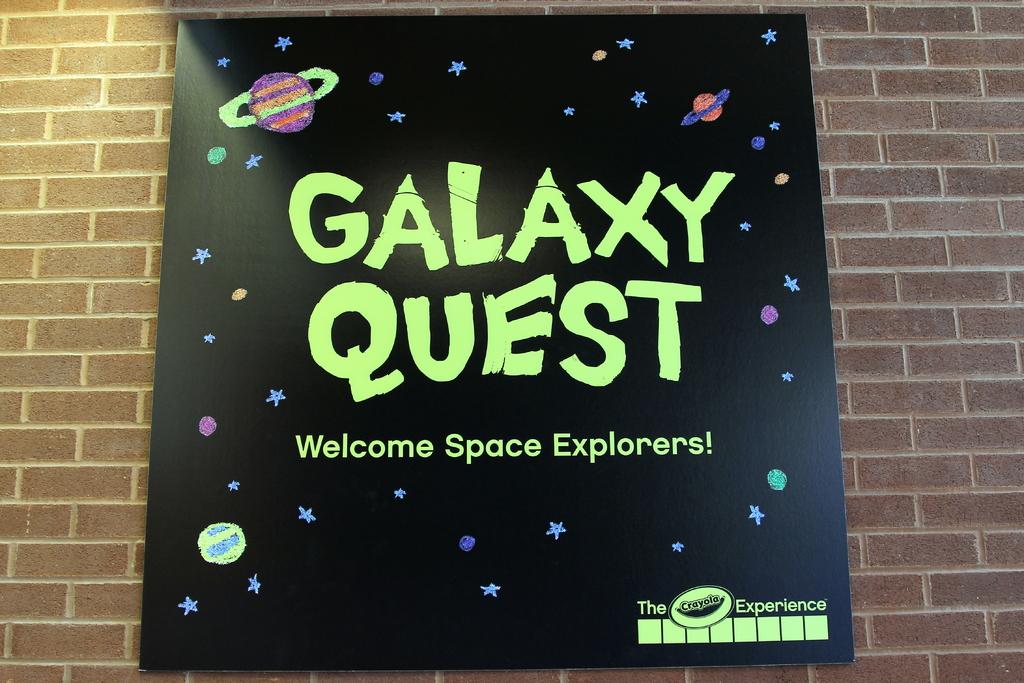What kind of explorers does galaxy quest welcome?
Provide a succinct answer. Space. What is the word after the in the bottom right corner?
Make the answer very short. Experience. 